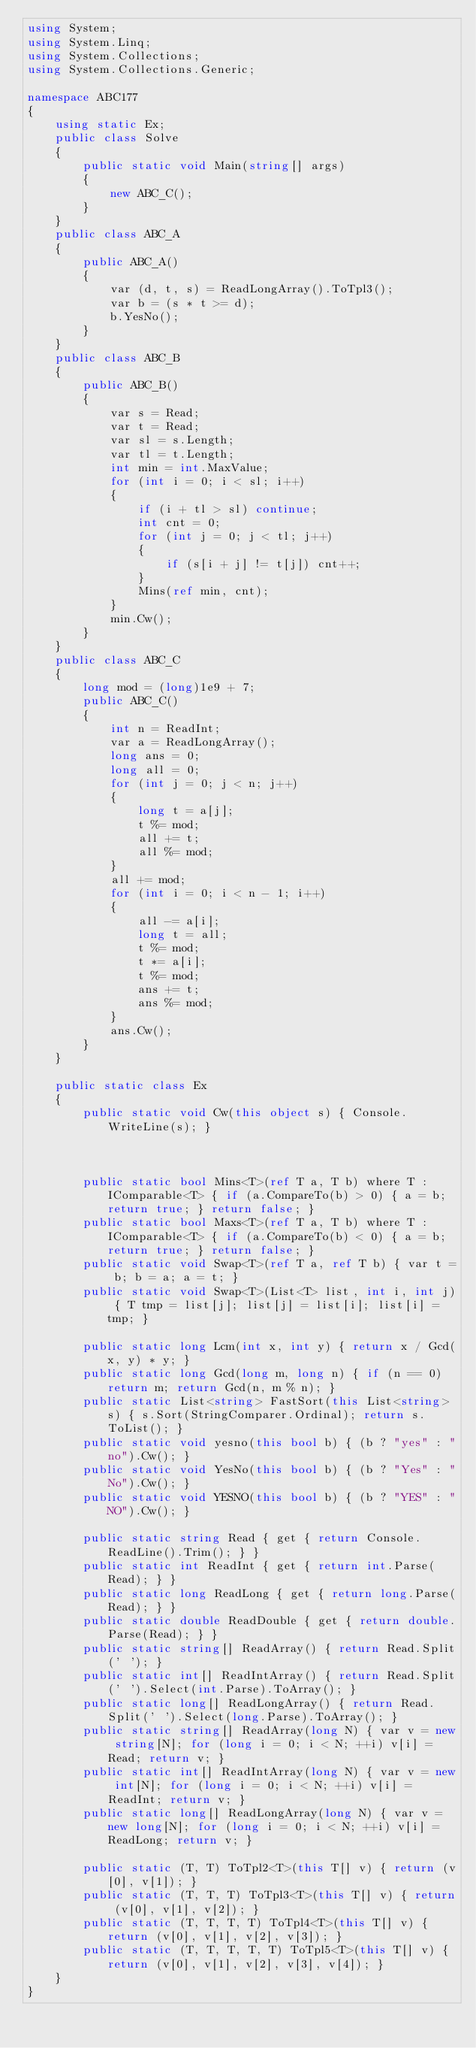<code> <loc_0><loc_0><loc_500><loc_500><_C#_>using System;
using System.Linq;
using System.Collections;
using System.Collections.Generic;

namespace ABC177
{
    using static Ex;
    public class Solve
    {
        public static void Main(string[] args)
        {
            new ABC_C();
        }
    }
    public class ABC_A
    {
        public ABC_A()
        {
            var (d, t, s) = ReadLongArray().ToTpl3();
            var b = (s * t >= d);
            b.YesNo();
        }
    }
    public class ABC_B
    {
        public ABC_B()
        {
            var s = Read;
            var t = Read;
            var sl = s.Length;
            var tl = t.Length;
            int min = int.MaxValue;
            for (int i = 0; i < sl; i++)
            {
                if (i + tl > sl) continue;
                int cnt = 0;
                for (int j = 0; j < tl; j++)
                {
                    if (s[i + j] != t[j]) cnt++;
                }
                Mins(ref min, cnt);
            }
            min.Cw();
        }
    }
    public class ABC_C
    {
        long mod = (long)1e9 + 7;
        public ABC_C()
        {
            int n = ReadInt;
            var a = ReadLongArray();
            long ans = 0;
            long all = 0;
            for (int j = 0; j < n; j++)
            {
                long t = a[j];
                t %= mod;
                all += t;
                all %= mod;
            }
            all += mod;
            for (int i = 0; i < n - 1; i++)
            {
                all -= a[i];
                long t = all;
                t %= mod;
                t *= a[i];
                t %= mod;
                ans += t;
                ans %= mod;
            }
            ans.Cw();
        }
    }

    public static class Ex
    {
        public static void Cw(this object s) { Console.WriteLine(s); }



        public static bool Mins<T>(ref T a, T b) where T : IComparable<T> { if (a.CompareTo(b) > 0) { a = b; return true; } return false; }
        public static bool Maxs<T>(ref T a, T b) where T : IComparable<T> { if (a.CompareTo(b) < 0) { a = b; return true; } return false; }
        public static void Swap<T>(ref T a, ref T b) { var t = b; b = a; a = t; }
        public static void Swap<T>(List<T> list, int i, int j) { T tmp = list[j]; list[j] = list[i]; list[i] = tmp; }

        public static long Lcm(int x, int y) { return x / Gcd(x, y) * y; }
        public static long Gcd(long m, long n) { if (n == 0) return m; return Gcd(n, m % n); }
        public static List<string> FastSort(this List<string> s) { s.Sort(StringComparer.Ordinal); return s.ToList(); }
        public static void yesno(this bool b) { (b ? "yes" : "no").Cw(); }
        public static void YesNo(this bool b) { (b ? "Yes" : "No").Cw(); }
        public static void YESNO(this bool b) { (b ? "YES" : "NO").Cw(); }

        public static string Read { get { return Console.ReadLine().Trim(); } }
        public static int ReadInt { get { return int.Parse(Read); } }
        public static long ReadLong { get { return long.Parse(Read); } }
        public static double ReadDouble { get { return double.Parse(Read); } }
        public static string[] ReadArray() { return Read.Split(' '); }
        public static int[] ReadIntArray() { return Read.Split(' ').Select(int.Parse).ToArray(); }
        public static long[] ReadLongArray() { return Read.Split(' ').Select(long.Parse).ToArray(); }
        public static string[] ReadArray(long N) { var v = new string[N]; for (long i = 0; i < N; ++i) v[i] = Read; return v; }
        public static int[] ReadIntArray(long N) { var v = new int[N]; for (long i = 0; i < N; ++i) v[i] = ReadInt; return v; }
        public static long[] ReadLongArray(long N) { var v = new long[N]; for (long i = 0; i < N; ++i) v[i] = ReadLong; return v; }

        public static (T, T) ToTpl2<T>(this T[] v) { return (v[0], v[1]); }
        public static (T, T, T) ToTpl3<T>(this T[] v) { return (v[0], v[1], v[2]); }
        public static (T, T, T, T) ToTpl4<T>(this T[] v) { return (v[0], v[1], v[2], v[3]); }
        public static (T, T, T, T, T) ToTpl5<T>(this T[] v) { return (v[0], v[1], v[2], v[3], v[4]); }
    }
}
</code> 